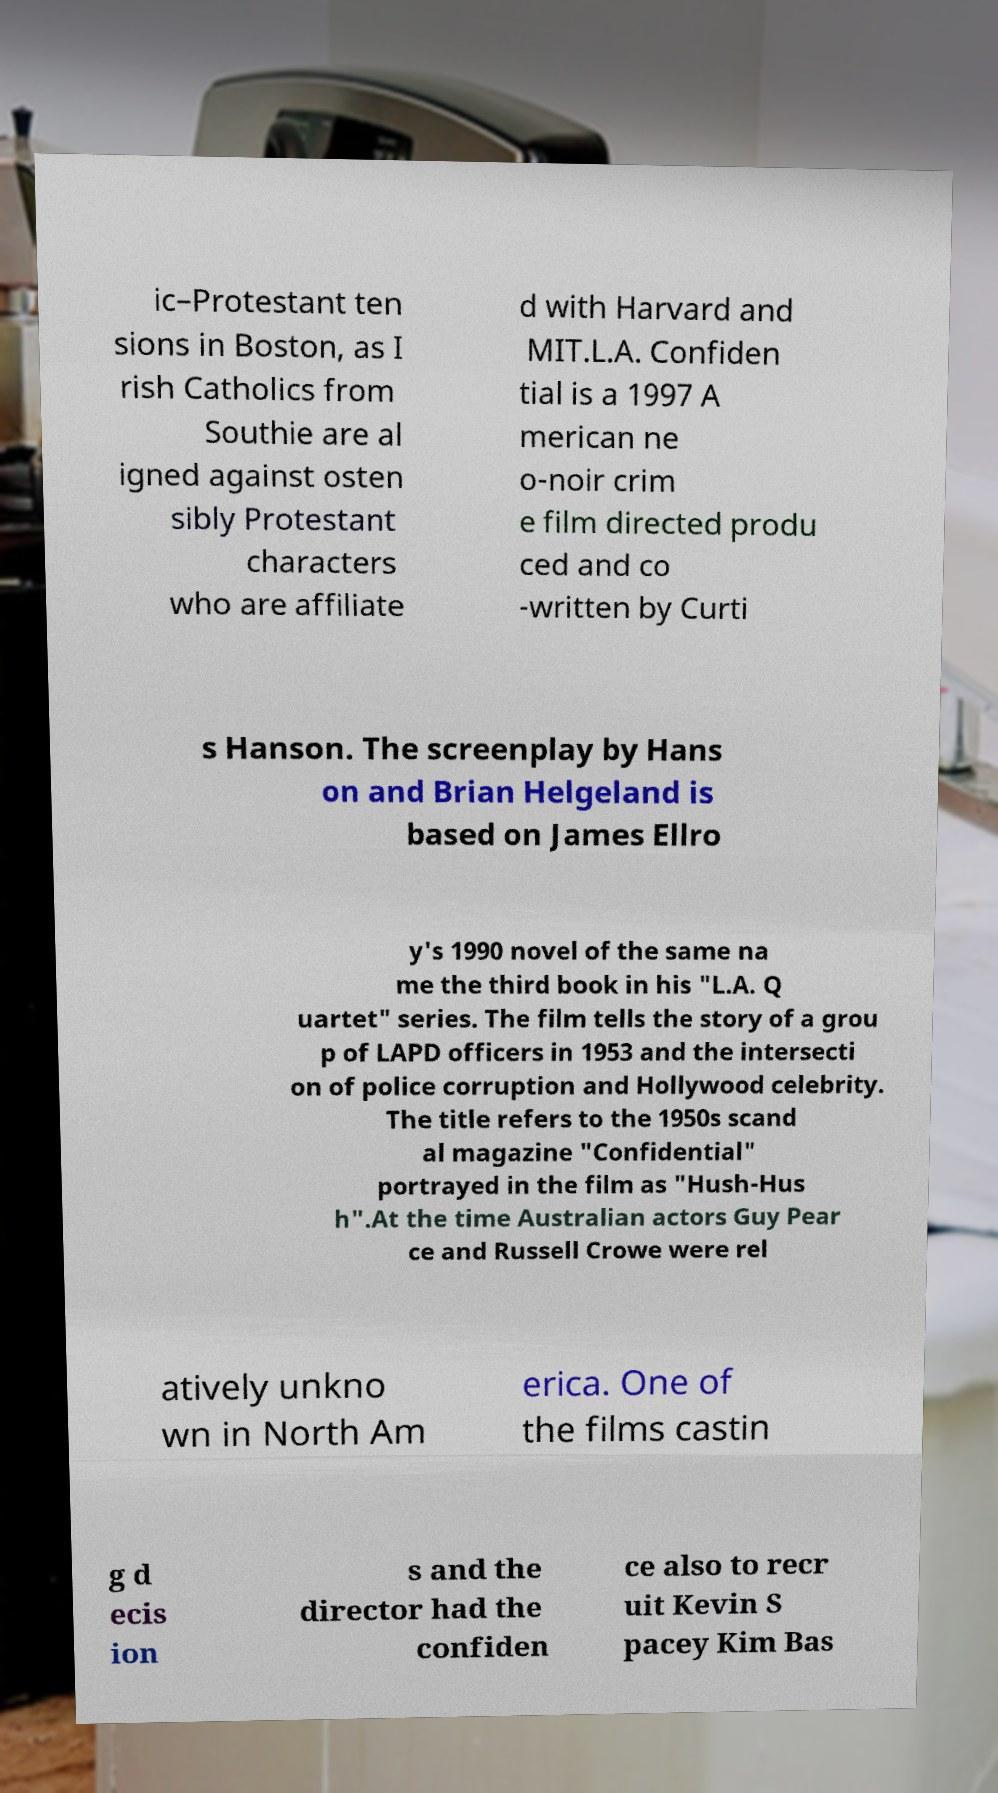I need the written content from this picture converted into text. Can you do that? ic–Protestant ten sions in Boston, as I rish Catholics from Southie are al igned against osten sibly Protestant characters who are affiliate d with Harvard and MIT.L.A. Confiden tial is a 1997 A merican ne o-noir crim e film directed produ ced and co -written by Curti s Hanson. The screenplay by Hans on and Brian Helgeland is based on James Ellro y's 1990 novel of the same na me the third book in his "L.A. Q uartet" series. The film tells the story of a grou p of LAPD officers in 1953 and the intersecti on of police corruption and Hollywood celebrity. The title refers to the 1950s scand al magazine "Confidential" portrayed in the film as "Hush-Hus h".At the time Australian actors Guy Pear ce and Russell Crowe were rel atively unkno wn in North Am erica. One of the films castin g d ecis ion s and the director had the confiden ce also to recr uit Kevin S pacey Kim Bas 